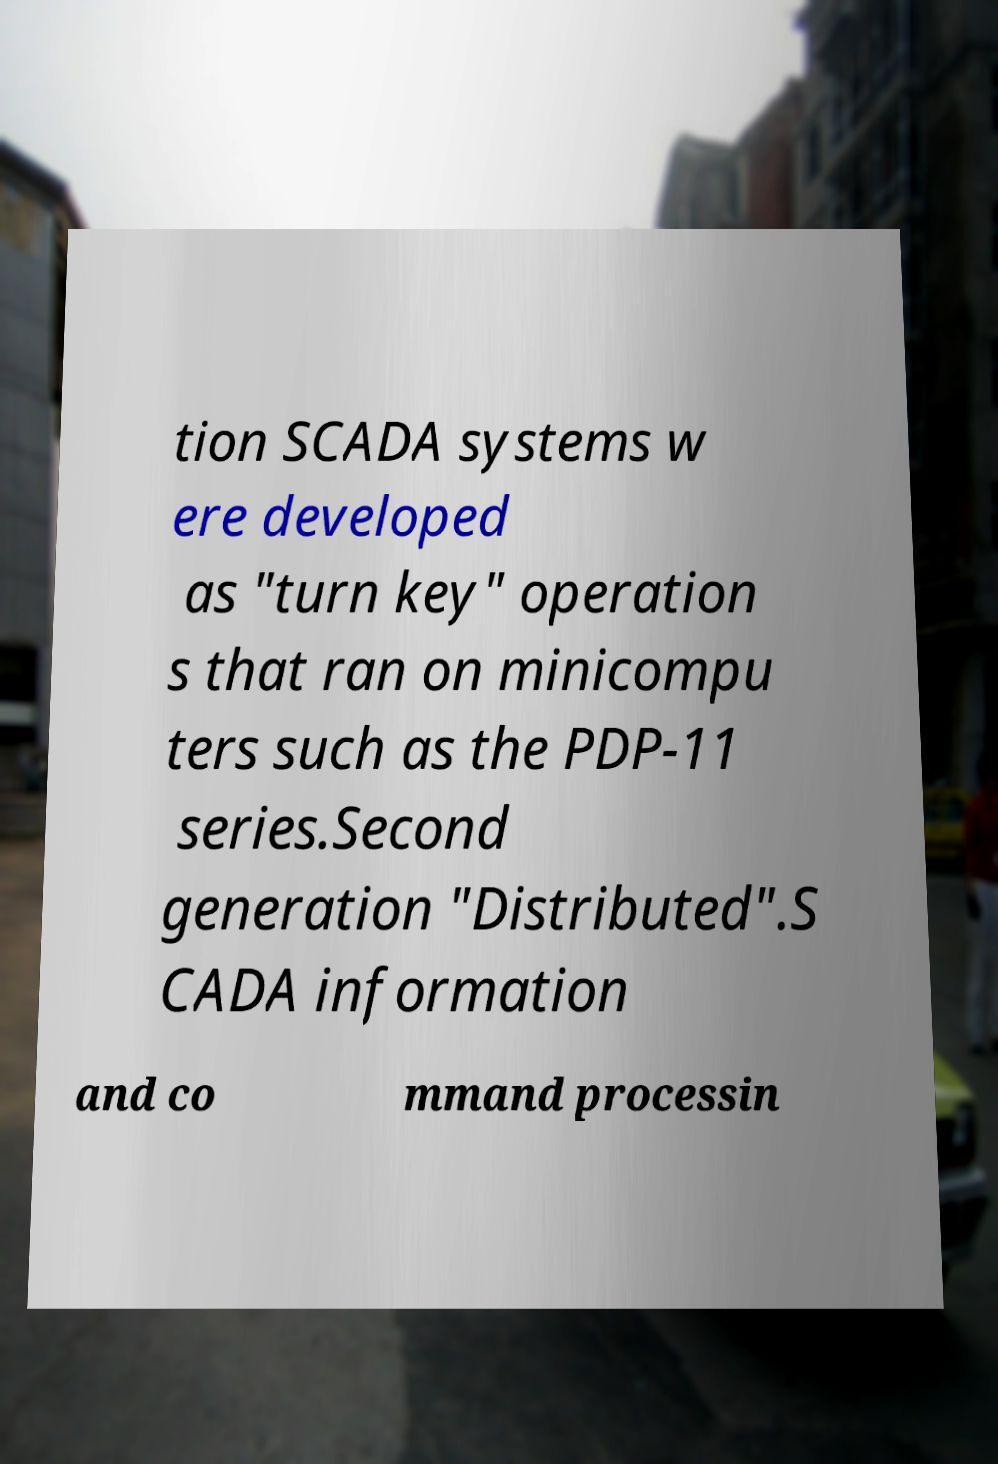I need the written content from this picture converted into text. Can you do that? tion SCADA systems w ere developed as "turn key" operation s that ran on minicompu ters such as the PDP-11 series.Second generation "Distributed".S CADA information and co mmand processin 